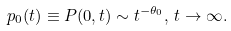Convert formula to latex. <formula><loc_0><loc_0><loc_500><loc_500>p _ { 0 } ( t ) \equiv P ( 0 , t ) \sim t ^ { - \theta _ { 0 } } , \, t \to \infty .</formula> 